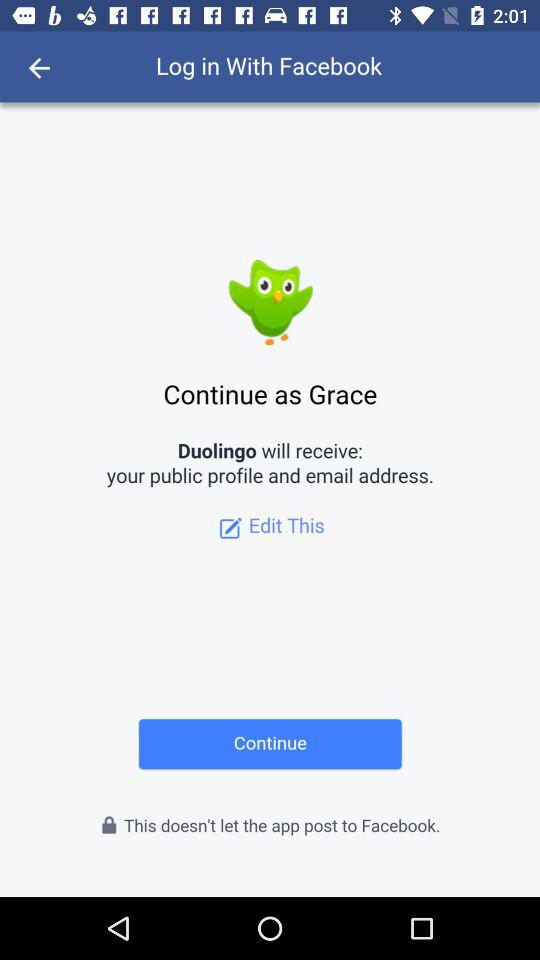What app will receive your email address? The app "Duolingo" will receive your email address. 